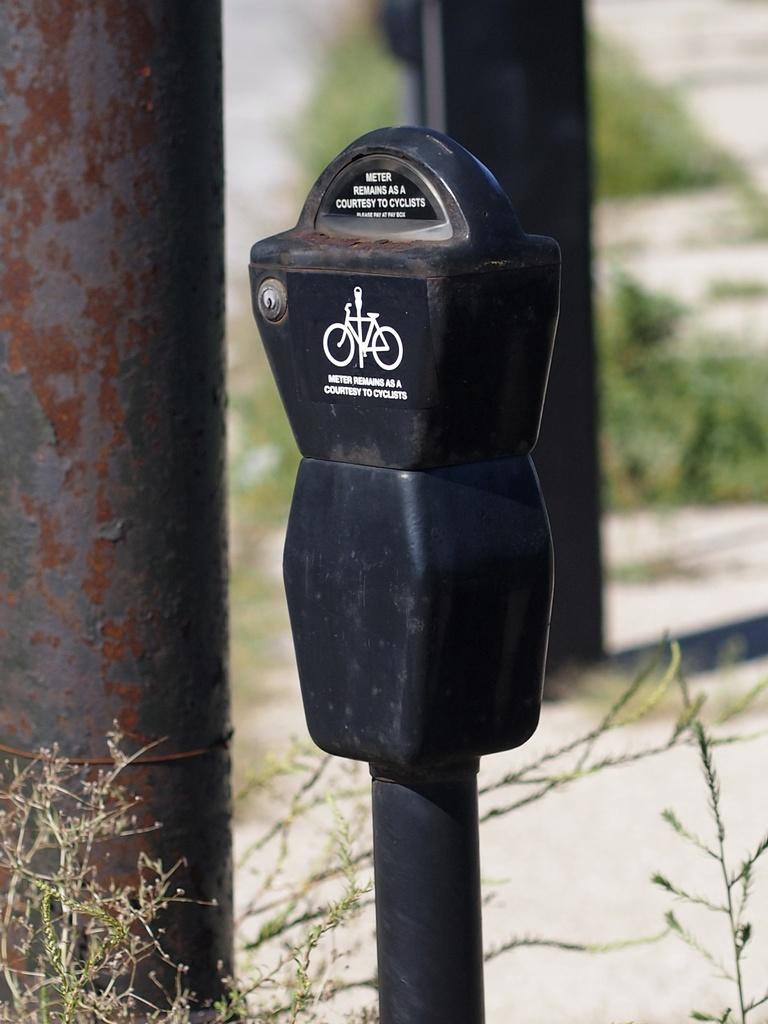What remains as a courtesy of cyclists?
Your answer should be very brief. Meter. 